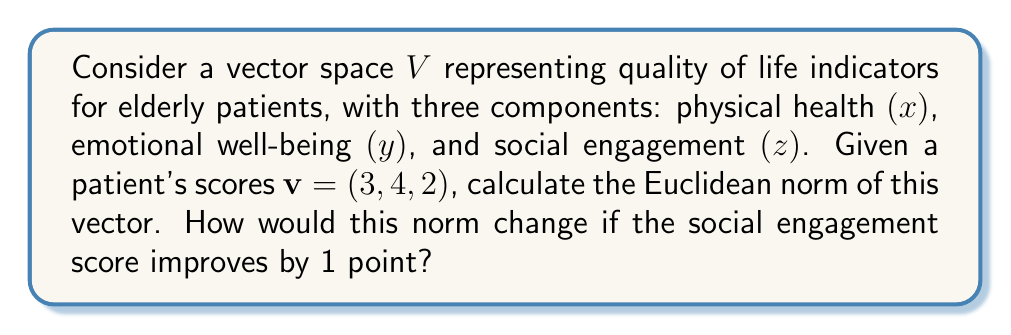Solve this math problem. To solve this problem, we'll follow these steps:

1) The Euclidean norm (also known as L2 norm) of a vector $v = (x, y, z)$ is defined as:

   $$\|v\| = \sqrt{x^2 + y^2 + z^2}$$

2) For the given vector $v = (3, 4, 2)$, we can calculate the norm:

   $$\|v\| = \sqrt{3^2 + 4^2 + 2^2} = \sqrt{9 + 16 + 4} = \sqrt{29}$$

3) To calculate how the norm would change if the social engagement score improves by 1 point, we need to recalculate the norm for the new vector $v' = (3, 4, 3)$:

   $$\|v'\| = \sqrt{3^2 + 4^2 + 3^2} = \sqrt{9 + 16 + 9} = \sqrt{34}$$

4) The change in norm is the difference between these two values:

   $$\Delta\|v\| = \|v'\| - \|v\| = \sqrt{34} - \sqrt{29}$$

This difference represents the quantitative improvement in the overall quality of life score when social engagement improves by 1 point, assuming equal weighting of all factors.
Answer: The Euclidean norm of the original vector is $\sqrt{29}$. After improving the social engagement score by 1 point, the new norm is $\sqrt{34}$. The change in norm is $\sqrt{34} - \sqrt{29}$. 